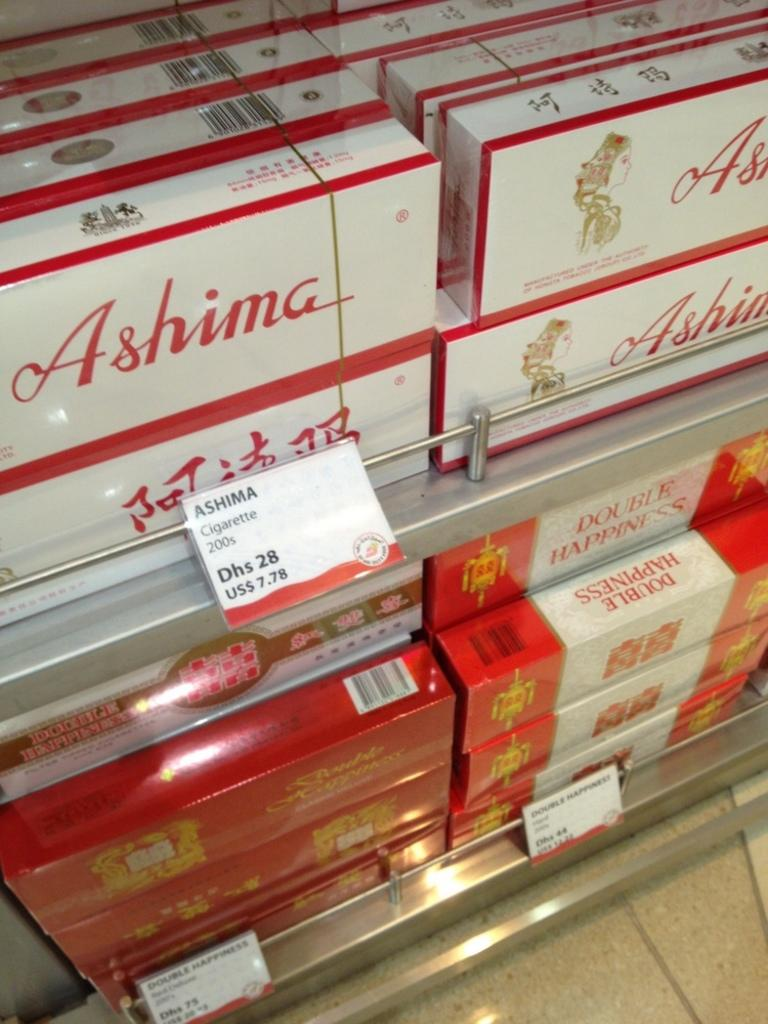<image>
Write a terse but informative summary of the picture. Many boxes of Ashima on display at a store. 